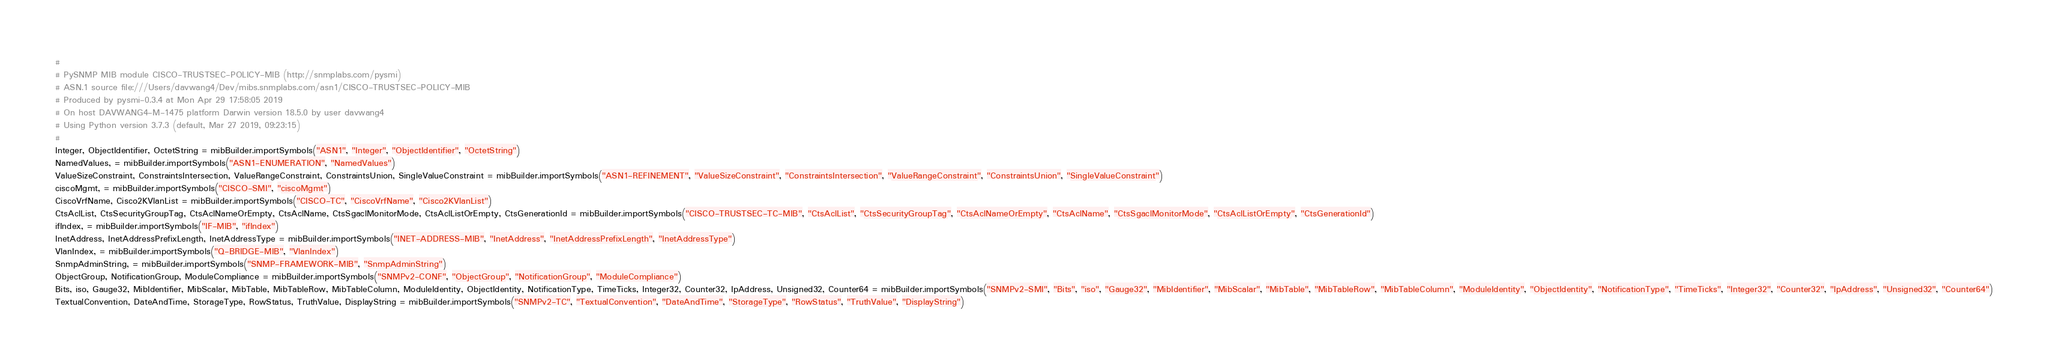<code> <loc_0><loc_0><loc_500><loc_500><_Python_>#
# PySNMP MIB module CISCO-TRUSTSEC-POLICY-MIB (http://snmplabs.com/pysmi)
# ASN.1 source file:///Users/davwang4/Dev/mibs.snmplabs.com/asn1/CISCO-TRUSTSEC-POLICY-MIB
# Produced by pysmi-0.3.4 at Mon Apr 29 17:58:05 2019
# On host DAVWANG4-M-1475 platform Darwin version 18.5.0 by user davwang4
# Using Python version 3.7.3 (default, Mar 27 2019, 09:23:15) 
#
Integer, ObjectIdentifier, OctetString = mibBuilder.importSymbols("ASN1", "Integer", "ObjectIdentifier", "OctetString")
NamedValues, = mibBuilder.importSymbols("ASN1-ENUMERATION", "NamedValues")
ValueSizeConstraint, ConstraintsIntersection, ValueRangeConstraint, ConstraintsUnion, SingleValueConstraint = mibBuilder.importSymbols("ASN1-REFINEMENT", "ValueSizeConstraint", "ConstraintsIntersection", "ValueRangeConstraint", "ConstraintsUnion", "SingleValueConstraint")
ciscoMgmt, = mibBuilder.importSymbols("CISCO-SMI", "ciscoMgmt")
CiscoVrfName, Cisco2KVlanList = mibBuilder.importSymbols("CISCO-TC", "CiscoVrfName", "Cisco2KVlanList")
CtsAclList, CtsSecurityGroupTag, CtsAclNameOrEmpty, CtsAclName, CtsSgaclMonitorMode, CtsAclListOrEmpty, CtsGenerationId = mibBuilder.importSymbols("CISCO-TRUSTSEC-TC-MIB", "CtsAclList", "CtsSecurityGroupTag", "CtsAclNameOrEmpty", "CtsAclName", "CtsSgaclMonitorMode", "CtsAclListOrEmpty", "CtsGenerationId")
ifIndex, = mibBuilder.importSymbols("IF-MIB", "ifIndex")
InetAddress, InetAddressPrefixLength, InetAddressType = mibBuilder.importSymbols("INET-ADDRESS-MIB", "InetAddress", "InetAddressPrefixLength", "InetAddressType")
VlanIndex, = mibBuilder.importSymbols("Q-BRIDGE-MIB", "VlanIndex")
SnmpAdminString, = mibBuilder.importSymbols("SNMP-FRAMEWORK-MIB", "SnmpAdminString")
ObjectGroup, NotificationGroup, ModuleCompliance = mibBuilder.importSymbols("SNMPv2-CONF", "ObjectGroup", "NotificationGroup", "ModuleCompliance")
Bits, iso, Gauge32, MibIdentifier, MibScalar, MibTable, MibTableRow, MibTableColumn, ModuleIdentity, ObjectIdentity, NotificationType, TimeTicks, Integer32, Counter32, IpAddress, Unsigned32, Counter64 = mibBuilder.importSymbols("SNMPv2-SMI", "Bits", "iso", "Gauge32", "MibIdentifier", "MibScalar", "MibTable", "MibTableRow", "MibTableColumn", "ModuleIdentity", "ObjectIdentity", "NotificationType", "TimeTicks", "Integer32", "Counter32", "IpAddress", "Unsigned32", "Counter64")
TextualConvention, DateAndTime, StorageType, RowStatus, TruthValue, DisplayString = mibBuilder.importSymbols("SNMPv2-TC", "TextualConvention", "DateAndTime", "StorageType", "RowStatus", "TruthValue", "DisplayString")</code> 